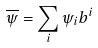<formula> <loc_0><loc_0><loc_500><loc_500>\overline { \psi } = \sum _ { i } \psi _ { i } b ^ { i }</formula> 